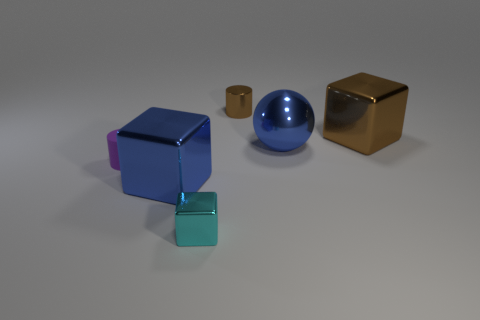Are there more tiny cyan metallic cubes than yellow rubber objects?
Provide a short and direct response. Yes. There is a metallic thing that is both on the left side of the ball and to the right of the small metal block; what is its size?
Provide a short and direct response. Small. There is a small brown metallic object; what shape is it?
Your answer should be very brief. Cylinder. Is there anything else that has the same size as the cyan shiny block?
Give a very brief answer. Yes. Is the number of purple cylinders that are right of the small purple cylinder greater than the number of big cyan matte blocks?
Ensure brevity in your answer.  No. There is a big shiny thing that is left of the tiny cylinder that is to the right of the big metal cube that is left of the big brown cube; what is its shape?
Offer a terse response. Cube. Is the size of the cylinder in front of the brown cylinder the same as the brown shiny cube?
Give a very brief answer. No. There is a object that is both right of the small brown cylinder and in front of the big brown thing; what shape is it?
Keep it short and to the point. Sphere. Is the color of the shiny sphere the same as the big metal cube to the right of the small shiny cylinder?
Give a very brief answer. No. The block in front of the large metallic cube to the left of the tiny shiny object in front of the brown shiny cube is what color?
Offer a very short reply. Cyan. 